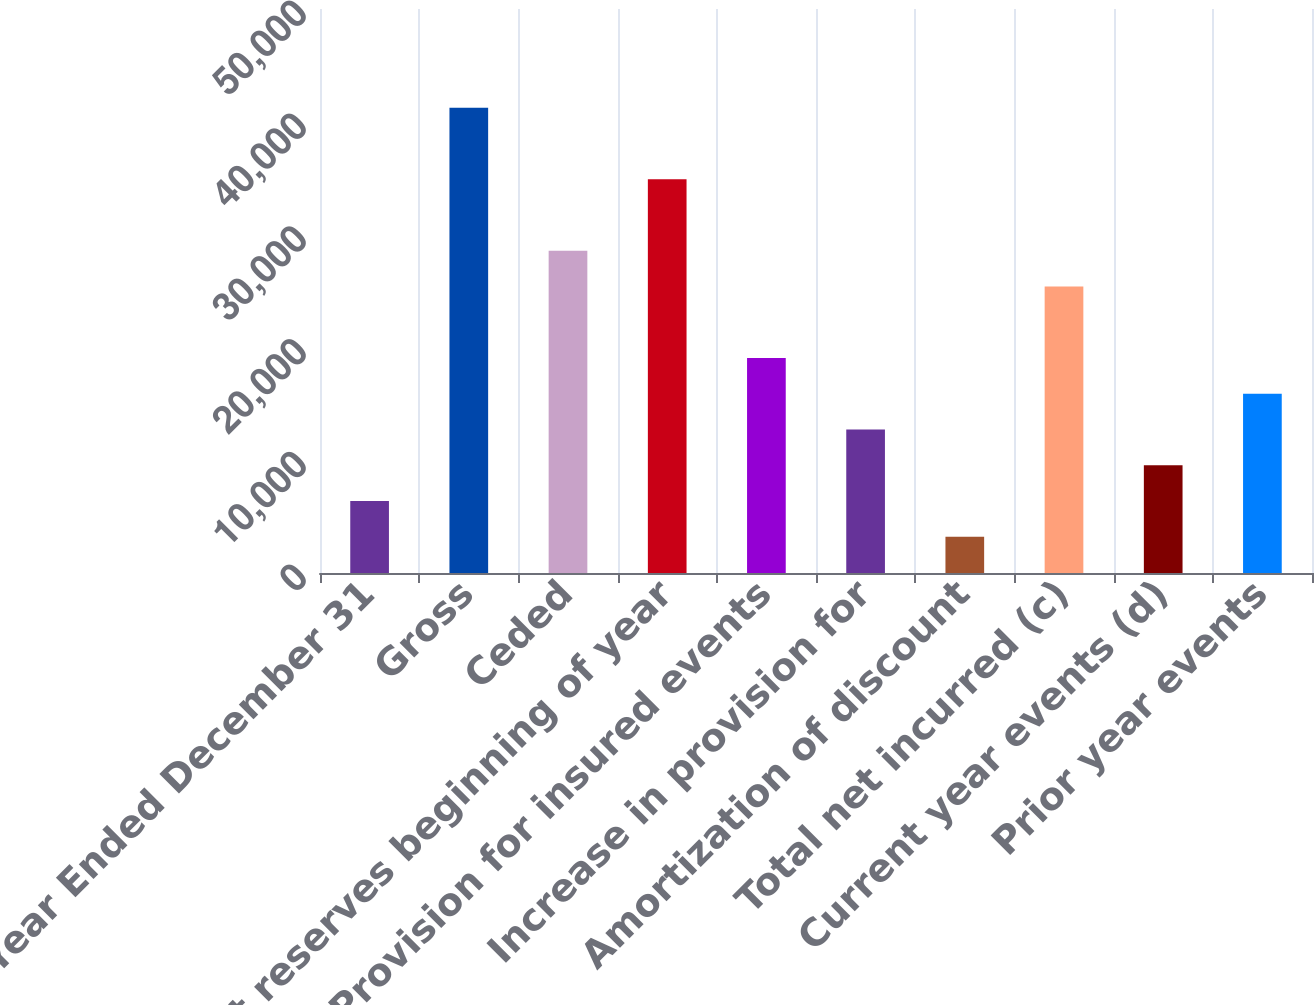Convert chart. <chart><loc_0><loc_0><loc_500><loc_500><bar_chart><fcel>Year Ended December 31<fcel>Gross<fcel>Ceded<fcel>Net reserves beginning of year<fcel>Provision for insured events<fcel>Increase in provision for<fcel>Amortization of discount<fcel>Total net incurred (c)<fcel>Current year events (d)<fcel>Prior year events<nl><fcel>6377.6<fcel>41239.9<fcel>28562.7<fcel>34901.3<fcel>19054.8<fcel>12716.2<fcel>3208.3<fcel>25393.4<fcel>9546.9<fcel>15885.5<nl></chart> 